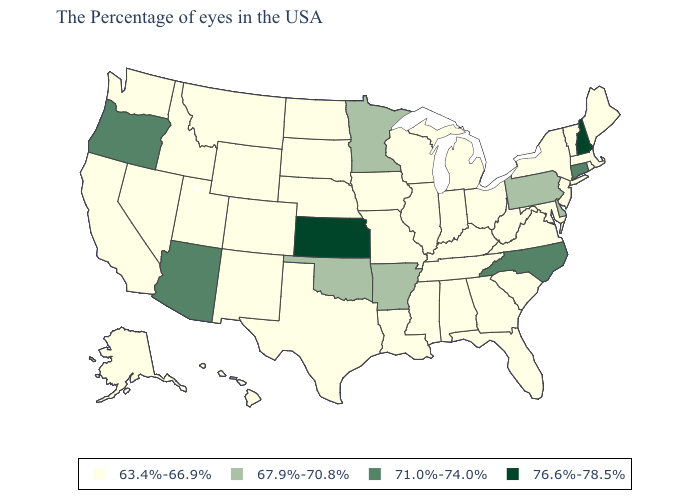What is the lowest value in the USA?
Keep it brief. 63.4%-66.9%. Does Montana have a lower value than Maine?
Short answer required. No. Name the states that have a value in the range 63.4%-66.9%?
Be succinct. Maine, Massachusetts, Rhode Island, Vermont, New York, New Jersey, Maryland, Virginia, South Carolina, West Virginia, Ohio, Florida, Georgia, Michigan, Kentucky, Indiana, Alabama, Tennessee, Wisconsin, Illinois, Mississippi, Louisiana, Missouri, Iowa, Nebraska, Texas, South Dakota, North Dakota, Wyoming, Colorado, New Mexico, Utah, Montana, Idaho, Nevada, California, Washington, Alaska, Hawaii. Name the states that have a value in the range 76.6%-78.5%?
Short answer required. New Hampshire, Kansas. What is the highest value in the MidWest ?
Keep it brief. 76.6%-78.5%. Name the states that have a value in the range 63.4%-66.9%?
Short answer required. Maine, Massachusetts, Rhode Island, Vermont, New York, New Jersey, Maryland, Virginia, South Carolina, West Virginia, Ohio, Florida, Georgia, Michigan, Kentucky, Indiana, Alabama, Tennessee, Wisconsin, Illinois, Mississippi, Louisiana, Missouri, Iowa, Nebraska, Texas, South Dakota, North Dakota, Wyoming, Colorado, New Mexico, Utah, Montana, Idaho, Nevada, California, Washington, Alaska, Hawaii. Name the states that have a value in the range 76.6%-78.5%?
Be succinct. New Hampshire, Kansas. What is the lowest value in the South?
Be succinct. 63.4%-66.9%. Is the legend a continuous bar?
Write a very short answer. No. Does Arkansas have a higher value than Iowa?
Quick response, please. Yes. What is the value of Pennsylvania?
Answer briefly. 67.9%-70.8%. How many symbols are there in the legend?
Write a very short answer. 4. Name the states that have a value in the range 71.0%-74.0%?
Short answer required. Connecticut, North Carolina, Arizona, Oregon. Which states have the lowest value in the West?
Be succinct. Wyoming, Colorado, New Mexico, Utah, Montana, Idaho, Nevada, California, Washington, Alaska, Hawaii. What is the lowest value in the USA?
Give a very brief answer. 63.4%-66.9%. 